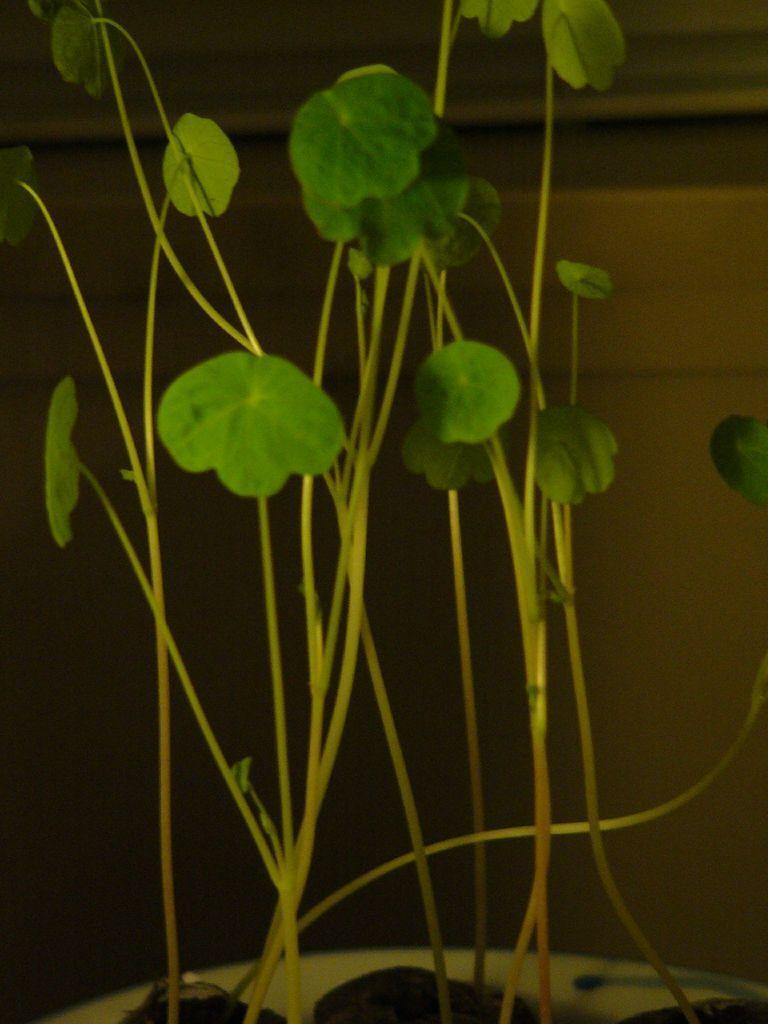Please provide a concise description of this image. In this image, we can see a houseplant. 